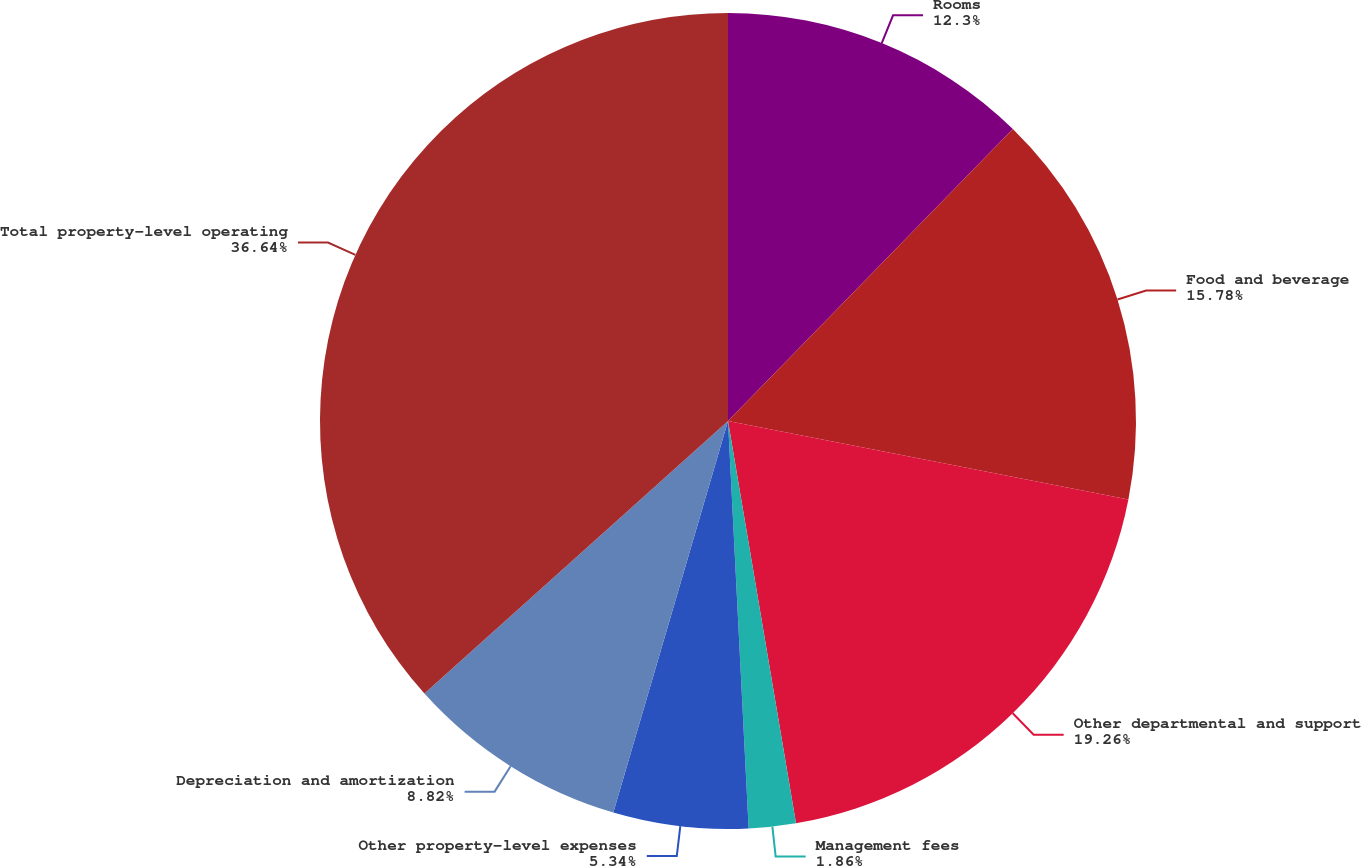<chart> <loc_0><loc_0><loc_500><loc_500><pie_chart><fcel>Rooms<fcel>Food and beverage<fcel>Other departmental and support<fcel>Management fees<fcel>Other property-level expenses<fcel>Depreciation and amortization<fcel>Total property-level operating<nl><fcel>12.3%<fcel>15.78%<fcel>19.26%<fcel>1.86%<fcel>5.34%<fcel>8.82%<fcel>36.65%<nl></chart> 